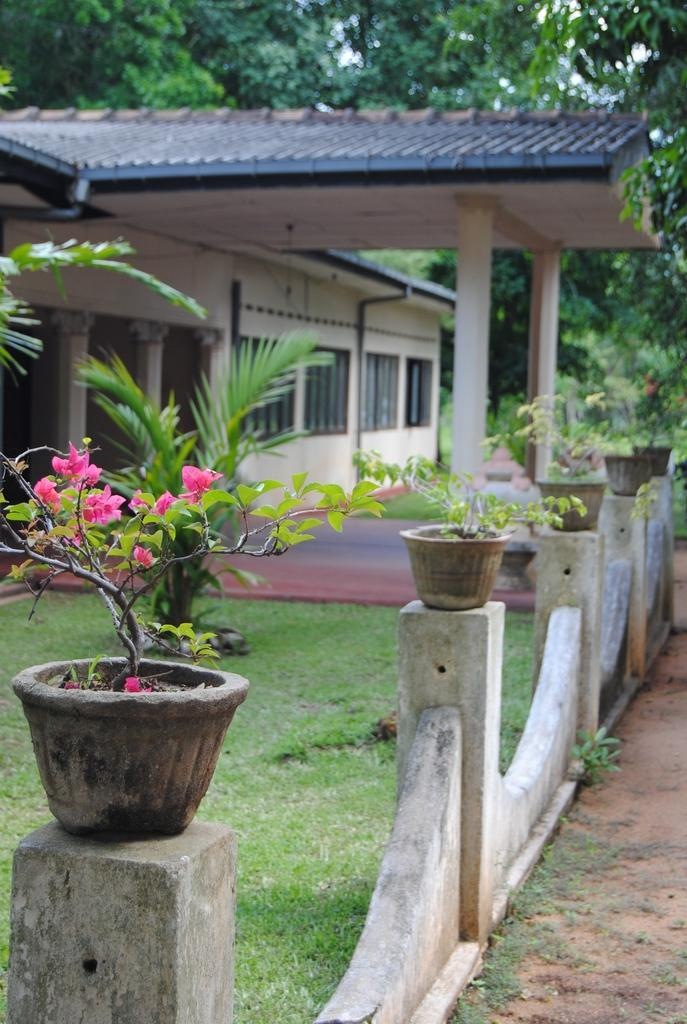What type of vegetation can be seen in the image? There is grass, plants, and flowers in the image. What type of structure is visible in the image? There is a house in the image. What can be seen in the background of the image? There are trees in the background of the image. What type of request is being made by the vessel in the image? There is no vessel present in the image, and therefore no request can be made. 